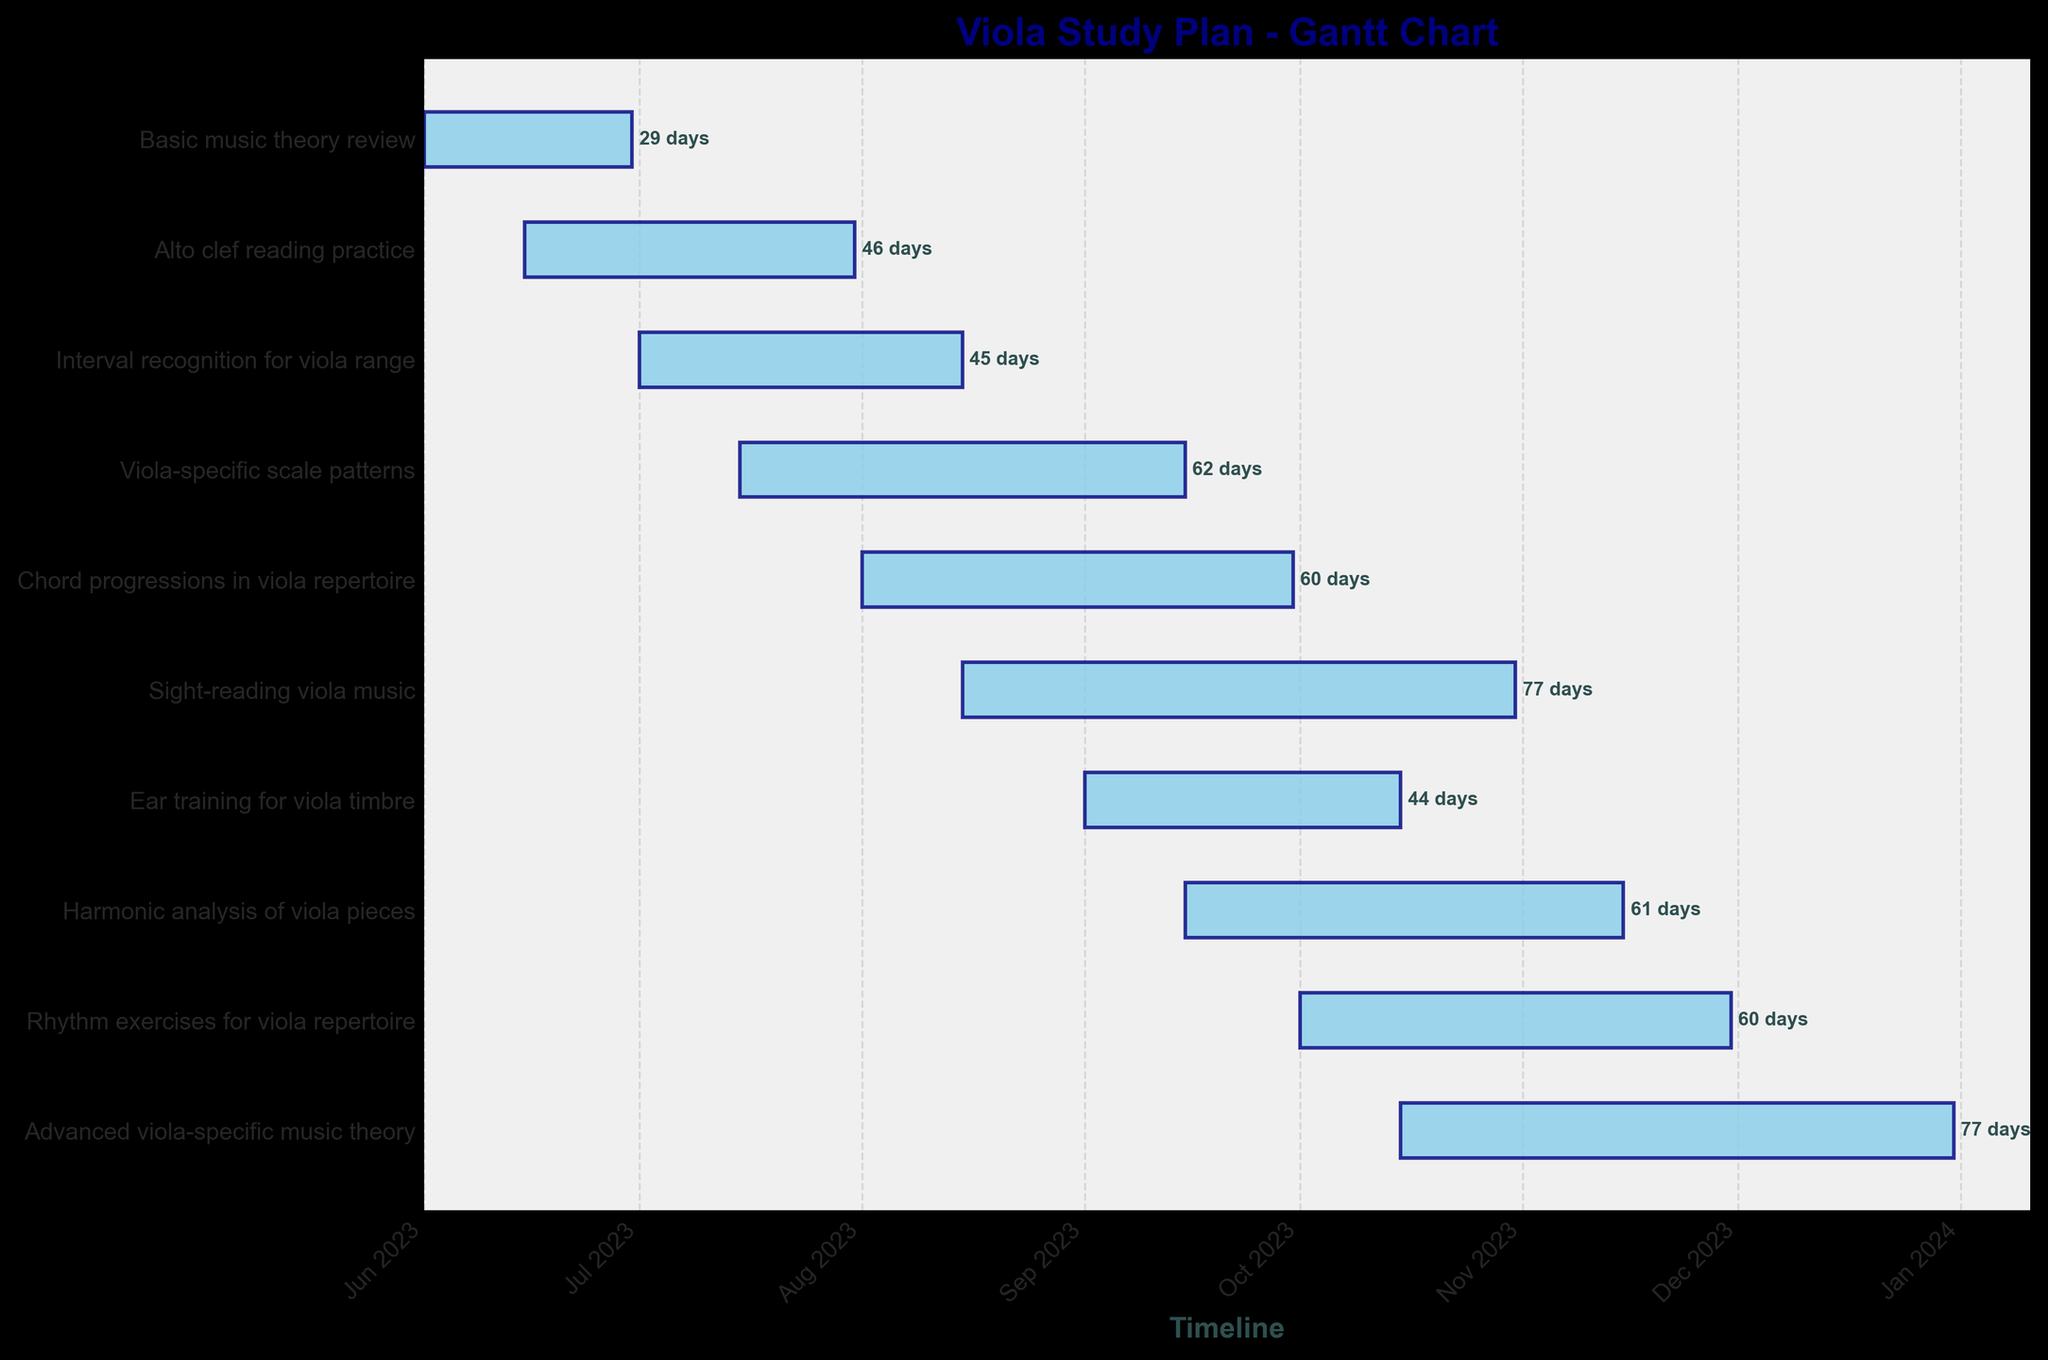What is the title of the Gantt Chart? The title is usually placed at the top of the chart and provides a concise summary of the entire visual representation. It is clearly visible and helps in understanding the context of the data.
Answer: Viola Study Plan - Gantt Chart How many tasks are shown on the Gantt Chart? Count all the different horizontal bars representing each task on the y-axis. Each bar corresponds to one task listed.
Answer: 10 What is the duration of the "Alto clef reading practice" task? Locate the specific task on the y-axis. Follow the horizontal bar to its right end where the duration in days is labeled.
Answer: 47 days Which task overlaps with "Interval recognition for viola range"? Look at the "Interval recognition for viola range" bar and identify any bars that start before it ends and end after it starts.
Answer: Viola-specific scale patterns Which task has the longest duration? Compare the lengths of all the horizontal bars. The longest bar indicates the task with the longest duration.
Answer: Sight-reading viola music What is the starting date for the "Ear training for viola timbre" task? Locate the task on the y-axis and follow it to the beginning of its horizontal bar. The date at the left end is the starting date.
Answer: September 1, 2023 How many tasks start in June 2023? Identify all tasks that have their starting points within the month of June 2023 by looking at the beginning of each horizontal bar.
Answer: 2 By how many days does the "Chord progressions in viola repertoire" task extend beyond "Viola-specific scale patterns"? Determine the end dates of both tasks and calculate the difference in days between them.
Answer: 15 days What is the total duration of all tasks that progress at least partly in July 2023? Identify the tasks lasting at least partly in July 2023, check their individual durations, and sum those up.
Answer: Basic music theory review: 30, Alto clef reading practice: 47, Interval recognition for viola range: 46, Viola-specific scale patterns: 63, sum = 186 days 